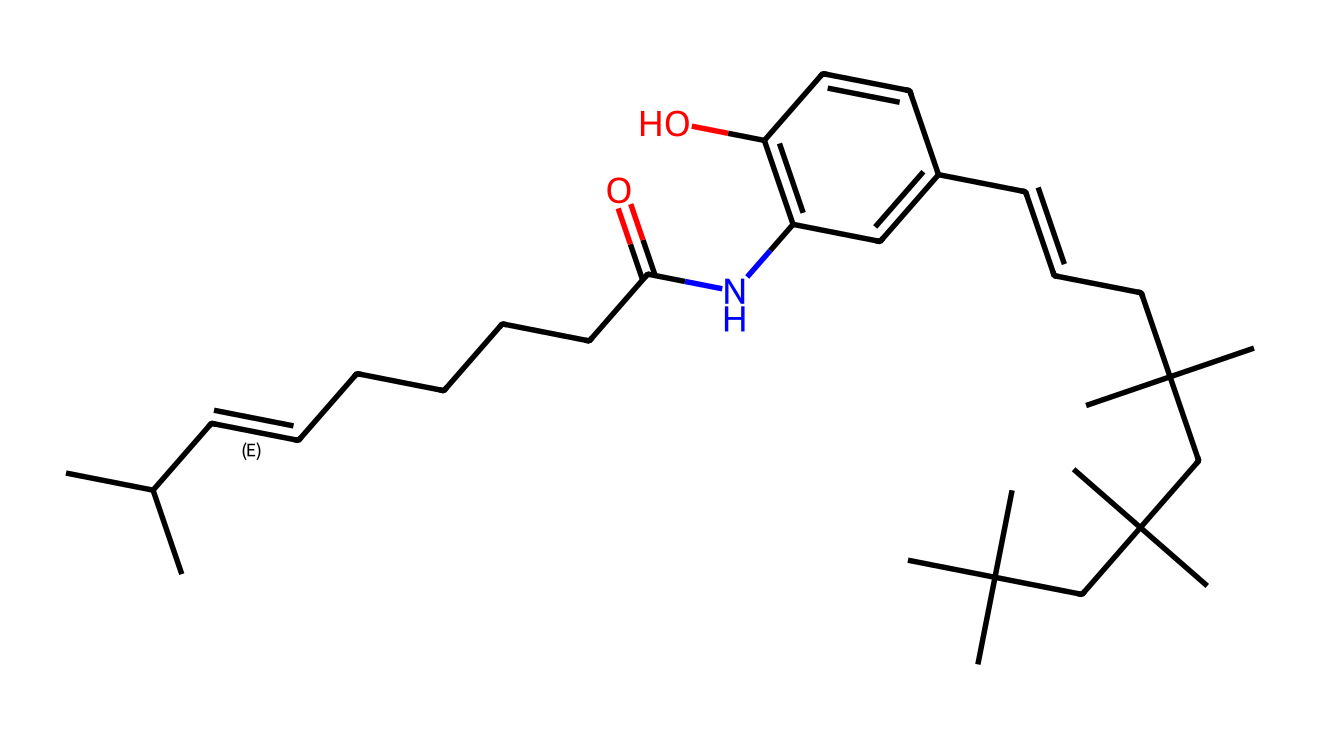What is the molecular formula of capsaicin? To determine the molecular formula, we can analyze the SMILES representation and count the number of each type of atom. The key atoms present include carbon (C), hydrogen (H), oxygen (O), and nitrogen (N). Counting the instances from the SMILES reveals 18 carbons, 27 hydrogens, 1 nitrogen, and 1 oxygen, leading to the formula C18H27NO.
Answer: C18H27NO How many rings are present in the structure of capsaicin? Analyzing the SMILES representation, we look for numbers indicating cyclic structures. There is one occurrence of '1', marking the start and end of a ring in the structure. Thus, there is one ring in capsaicin.
Answer: 1 What functional groups are present in capsaicin? From the SMILES representation, we can identify various functional groups. Notably, there is an amide group (indicated by 'NC(=O)') and a hydroxyl group (indicated by 'O'). These indicate the presence of both an amide and an alcohol functional group in capsaicin.
Answer: amide, alcohol What type of compound is capsaicin classified as? Capsaicin is categorized based on its chemical structure and biological activity. Specifically, it is recognized as a bioactive compound due to its role in provoking spiciness in foods; it primarily exhibits properties of an alkaloid.
Answer: alkaloid How many double bonds are present in the chemical structure of capsaicin? To find the number of double bonds, we can look for '=' in the SMILES. There are two double bonds indicated by ‘C=C’ in the representation. Therefore, there are two double bonds present in capsaicin.
Answer: 2 What is the role of nitrogen in the structure of capsaicin? The presence of nitrogen within the chemical structure generally indicates that the compound can exhibit specific biological activities. In capsaicin, nitrogen is part of the amide functional group contributing to its interaction with nociceptors, making it responsible for the heat sensation.
Answer: pain receptor interaction 